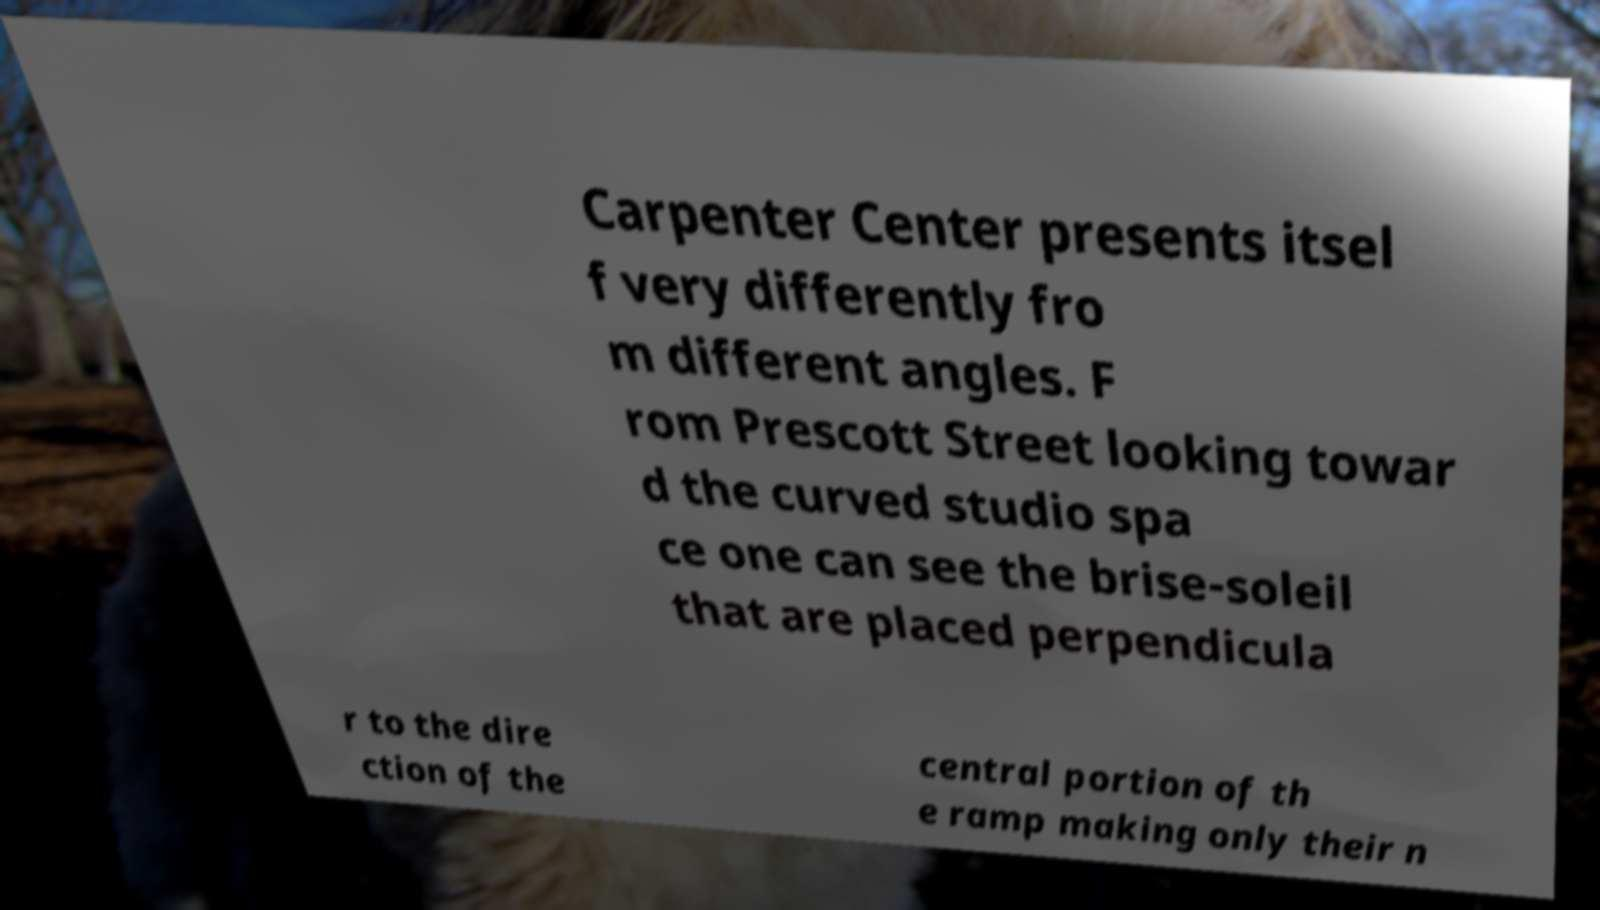What messages or text are displayed in this image? I need them in a readable, typed format. Carpenter Center presents itsel f very differently fro m different angles. F rom Prescott Street looking towar d the curved studio spa ce one can see the brise-soleil that are placed perpendicula r to the dire ction of the central portion of th e ramp making only their n 